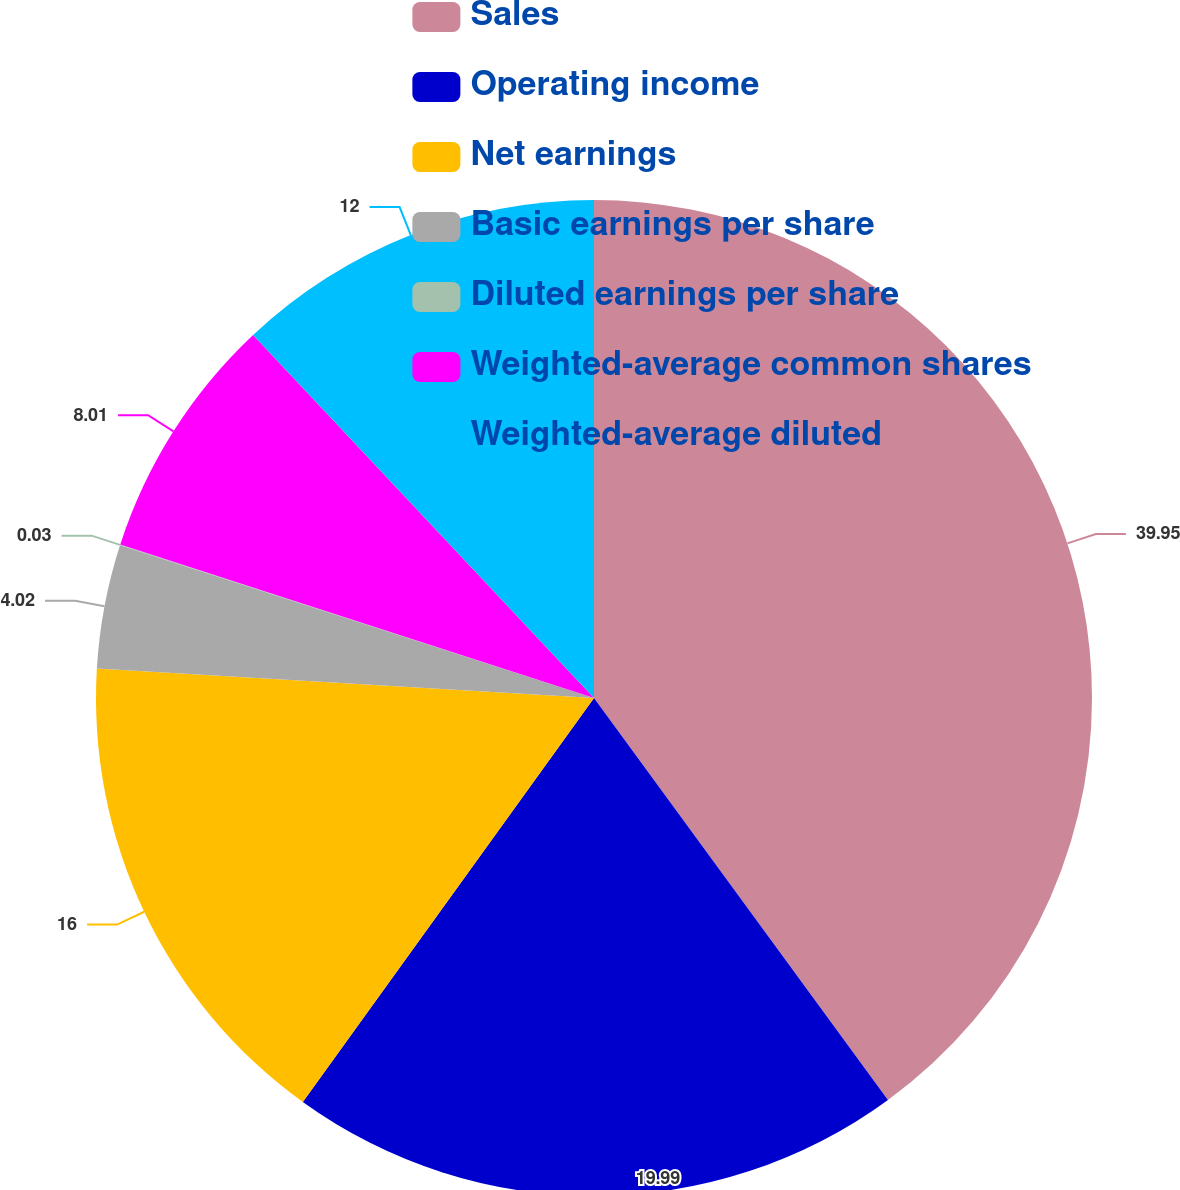Convert chart. <chart><loc_0><loc_0><loc_500><loc_500><pie_chart><fcel>Sales<fcel>Operating income<fcel>Net earnings<fcel>Basic earnings per share<fcel>Diluted earnings per share<fcel>Weighted-average common shares<fcel>Weighted-average diluted<nl><fcel>39.95%<fcel>19.99%<fcel>16.0%<fcel>4.02%<fcel>0.03%<fcel>8.01%<fcel>12.0%<nl></chart> 